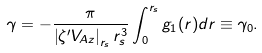Convert formula to latex. <formula><loc_0><loc_0><loc_500><loc_500>\gamma = - \frac { \pi } { \left | \zeta ^ { \prime } V _ { A z } \right | _ { r _ { s } } r _ { s } ^ { 3 } } \int _ { 0 } ^ { r _ { s } } g _ { 1 } ( r ) d r \equiv \gamma _ { 0 } .</formula> 